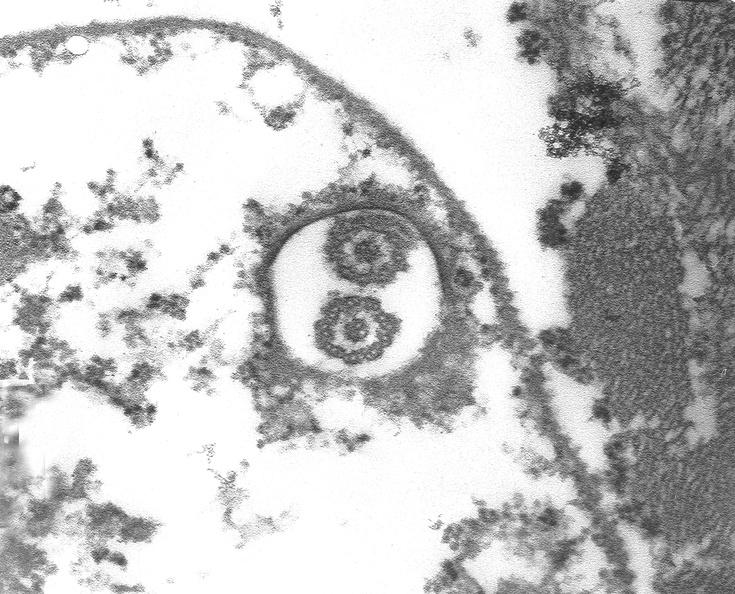what is present?
Answer the question using a single word or phrase. Cardiovascular 